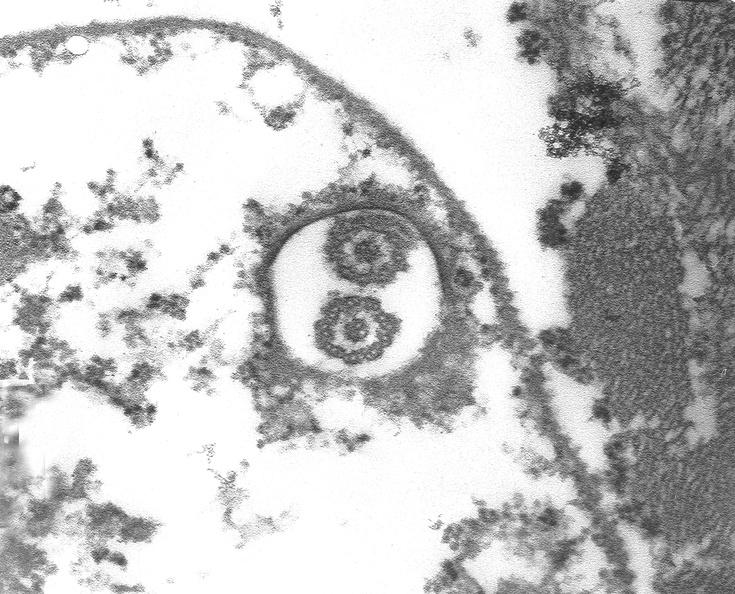what is present?
Answer the question using a single word or phrase. Cardiovascular 